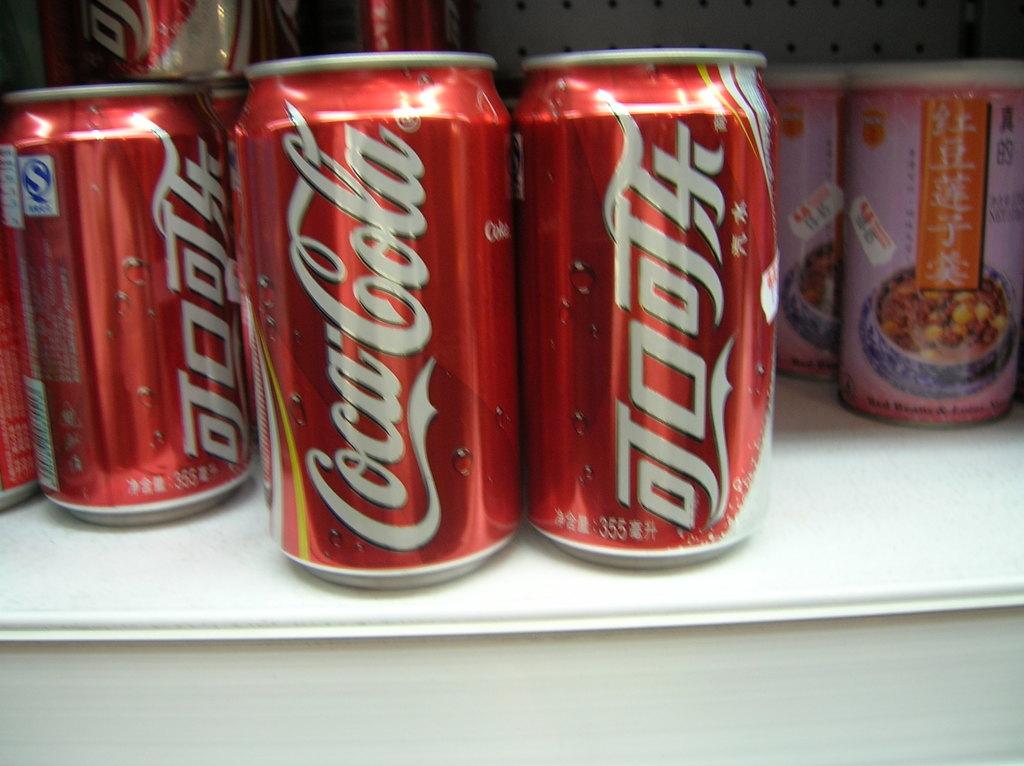What brand name soda is next to this off-brand imposter?
Your answer should be compact. Coca cola. What is the left brand of soda?
Your response must be concise. Coca cola. 